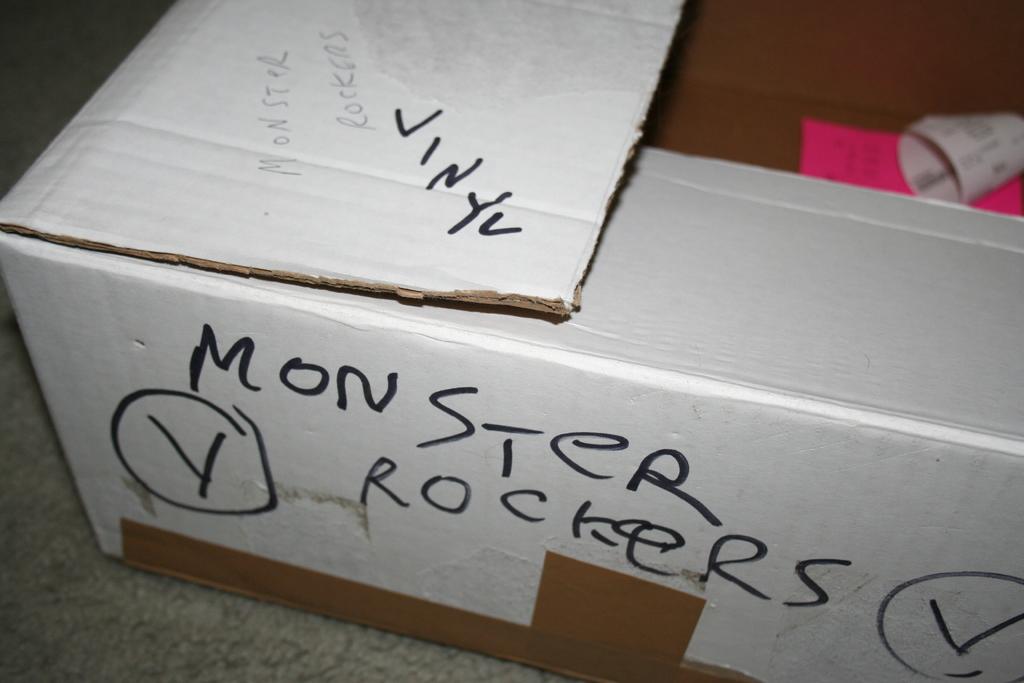What material is written on the box?
Ensure brevity in your answer.  Vinyl. 